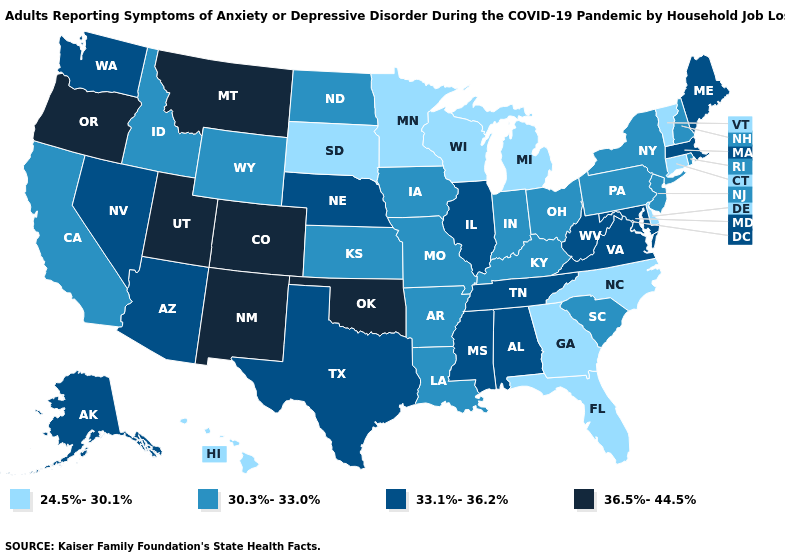What is the value of New Hampshire?
Give a very brief answer. 30.3%-33.0%. Name the states that have a value in the range 36.5%-44.5%?
Short answer required. Colorado, Montana, New Mexico, Oklahoma, Oregon, Utah. What is the lowest value in the MidWest?
Quick response, please. 24.5%-30.1%. What is the value of Vermont?
Answer briefly. 24.5%-30.1%. What is the value of Wyoming?
Keep it brief. 30.3%-33.0%. Is the legend a continuous bar?
Quick response, please. No. What is the value of Minnesota?
Quick response, please. 24.5%-30.1%. Name the states that have a value in the range 30.3%-33.0%?
Give a very brief answer. Arkansas, California, Idaho, Indiana, Iowa, Kansas, Kentucky, Louisiana, Missouri, New Hampshire, New Jersey, New York, North Dakota, Ohio, Pennsylvania, Rhode Island, South Carolina, Wyoming. Name the states that have a value in the range 33.1%-36.2%?
Write a very short answer. Alabama, Alaska, Arizona, Illinois, Maine, Maryland, Massachusetts, Mississippi, Nebraska, Nevada, Tennessee, Texas, Virginia, Washington, West Virginia. What is the highest value in the South ?
Keep it brief. 36.5%-44.5%. What is the lowest value in states that border Wisconsin?
Concise answer only. 24.5%-30.1%. What is the value of Washington?
Give a very brief answer. 33.1%-36.2%. What is the value of Wyoming?
Keep it brief. 30.3%-33.0%. Does Michigan have a lower value than Idaho?
Keep it brief. Yes. What is the value of Delaware?
Be succinct. 24.5%-30.1%. 